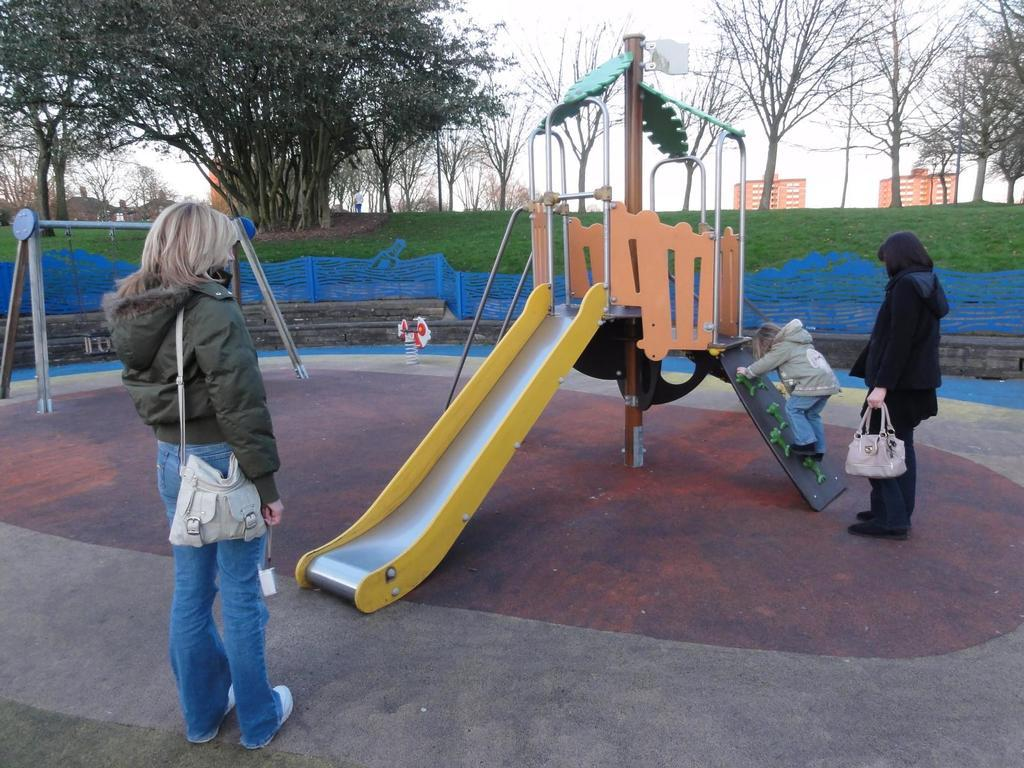How many people are in the image? There are two people in the image. What is the child doing in the image? The child is on a slider. What other playground equipment is visible in the image? There is a swing in the image. What color is the object mentioned in the image? There is a white color object in the image. What type of barrier is present in the image? There is a fence in the image. Where is one of the people located in the image? A person is under one of the trees. What type of structures can be seen in the image? There are buildings in the image. What type of ground surface is visible in the image? There is grass in the image. What part of the natural environment is visible in the image? The sky is visible in the image. What thought is the child having while on the slider? There is no indication of the child's thoughts in the image. How many bites of the grass did the person under the tree take? There is no indication of anyone eating grass in the image. 